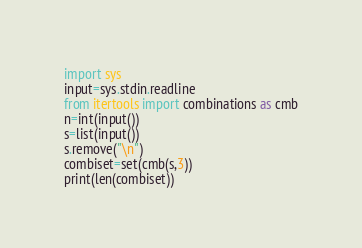Convert code to text. <code><loc_0><loc_0><loc_500><loc_500><_Python_>import sys
input=sys.stdin.readline
from itertools import combinations as cmb
n=int(input())
s=list(input())
s.remove("\n")
combiset=set(cmb(s,3))
print(len(combiset))</code> 